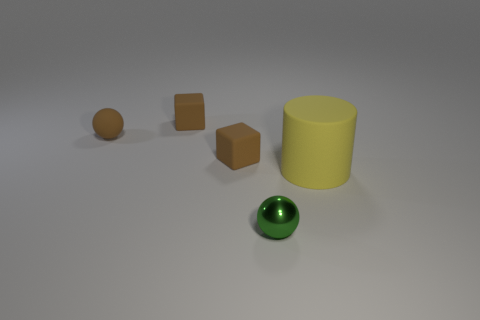There is a small rubber block that is behind the tiny brown sphere; does it have the same color as the matte ball?
Offer a terse response. Yes. How many brown objects are matte spheres or metallic balls?
Offer a terse response. 1. Is there anything else that has the same material as the green ball?
Provide a short and direct response. No. Do the object on the right side of the shiny ball and the tiny metallic thing in front of the large matte cylinder have the same shape?
Keep it short and to the point. No. How many brown cubes are there?
Your answer should be very brief. 2. What is the shape of the yellow thing that is made of the same material as the brown sphere?
Keep it short and to the point. Cylinder. Is there any other thing that is the same color as the big matte thing?
Offer a very short reply. No. There is a small shiny thing; is it the same color as the small sphere that is behind the small green metal object?
Give a very brief answer. No. Is the number of yellow rubber cylinders behind the brown rubber sphere less than the number of tiny metal cylinders?
Your answer should be compact. No. There is a tiny sphere that is behind the tiny metallic ball; what is its material?
Your response must be concise. Rubber. 